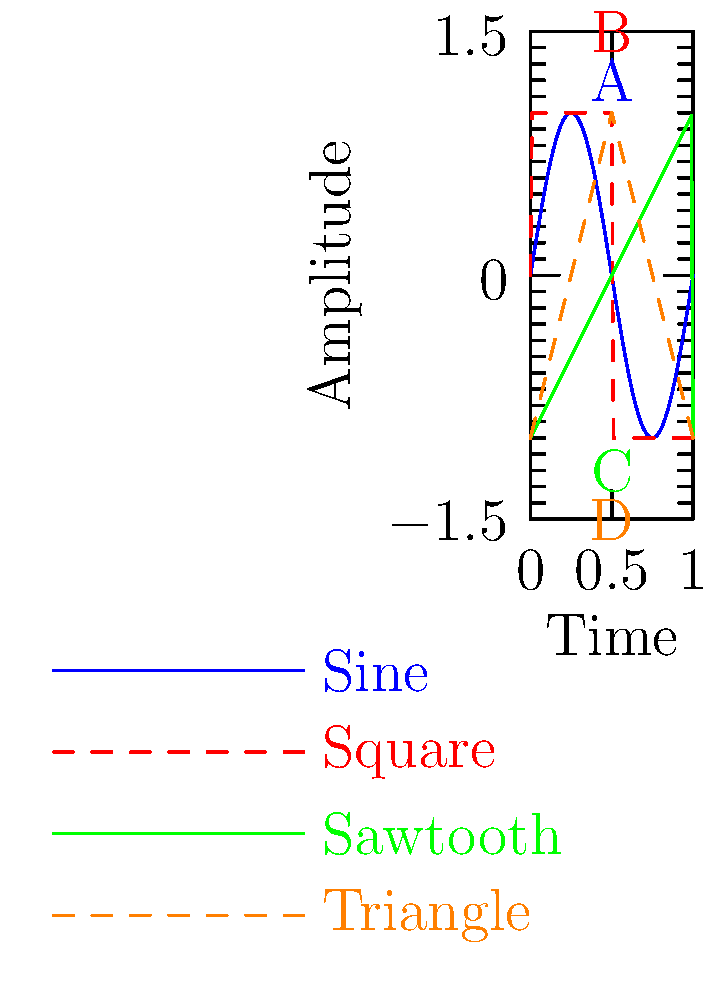As a professional musician, you're familiar with various audio waveforms. Match the labeled waveforms (A, B, C, D) to their corresponding instruments or sound sources:

1. Electric guitar with distortion
2. Flute
3. Synthesizer with low-pass filter
4. Violin played with a bow Let's analyze each waveform and match it to the most likely instrument or sound source:

1. Waveform A (Blue, Sine wave):
   - Smooth, rounded shape
   - Characteristic of pure tones or simple harmonic motion
   - Most closely resembles the sound of a flute, which produces a nearly sinusoidal waveform

2. Waveform B (Red, Square wave):
   - Abrupt transitions between high and low states
   - Rich in odd harmonics
   - Typical of heavily distorted electric guitar sounds

3. Waveform C (Green, Sawtooth wave):
   - Sharp rise followed by a linear fall
   - Rich in both odd and even harmonics
   - Common in synthesizers, especially when passed through a low-pass filter to round off the sharp edges

4. Waveform D (Orange, Triangle wave):
   - Linear rise and fall
   - Similar to a sine wave but with a more "pointed" shape
   - Resembles the sound of a bowed string instrument like a violin, which produces a waveform between a triangle and a sine wave

Therefore, the correct matches are:
A (Sine) - 2. Flute
B (Square) - 1. Electric guitar with distortion
C (Sawtooth) - 3. Synthesizer with low-pass filter
D (Triangle) - 4. Violin played with a bow
Answer: A-2, B-1, C-3, D-4 